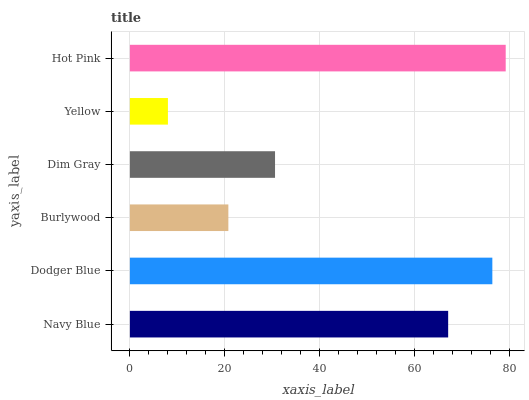Is Yellow the minimum?
Answer yes or no. Yes. Is Hot Pink the maximum?
Answer yes or no. Yes. Is Dodger Blue the minimum?
Answer yes or no. No. Is Dodger Blue the maximum?
Answer yes or no. No. Is Dodger Blue greater than Navy Blue?
Answer yes or no. Yes. Is Navy Blue less than Dodger Blue?
Answer yes or no. Yes. Is Navy Blue greater than Dodger Blue?
Answer yes or no. No. Is Dodger Blue less than Navy Blue?
Answer yes or no. No. Is Navy Blue the high median?
Answer yes or no. Yes. Is Dim Gray the low median?
Answer yes or no. Yes. Is Dodger Blue the high median?
Answer yes or no. No. Is Burlywood the low median?
Answer yes or no. No. 